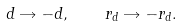<formula> <loc_0><loc_0><loc_500><loc_500>d \rightarrow - d , \quad r _ { d } \rightarrow - r _ { d } .</formula> 